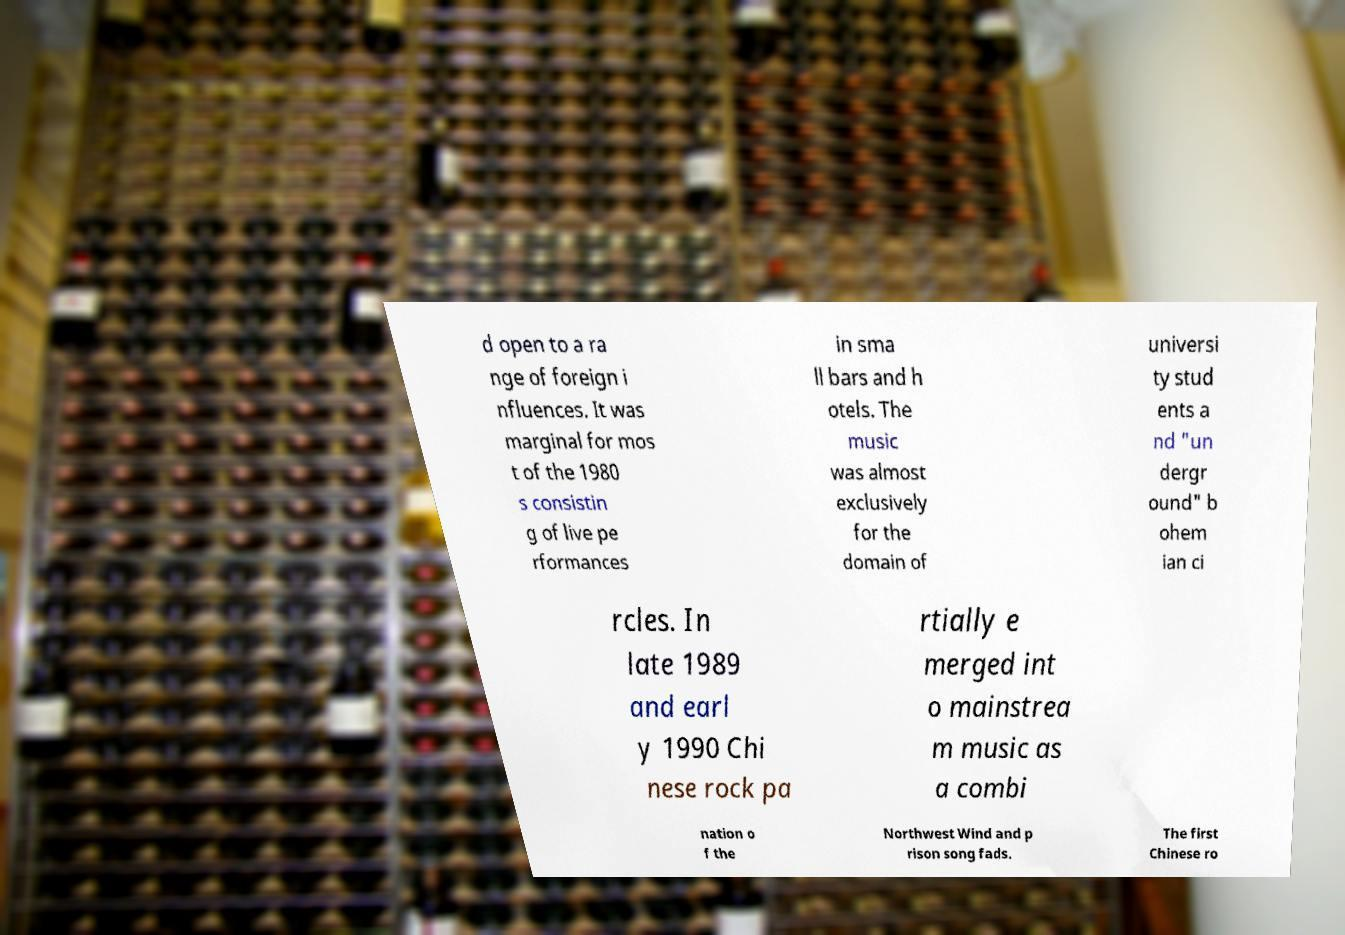Can you read and provide the text displayed in the image?This photo seems to have some interesting text. Can you extract and type it out for me? d open to a ra nge of foreign i nfluences. It was marginal for mos t of the 1980 s consistin g of live pe rformances in sma ll bars and h otels. The music was almost exclusively for the domain of universi ty stud ents a nd "un dergr ound" b ohem ian ci rcles. In late 1989 and earl y 1990 Chi nese rock pa rtially e merged int o mainstrea m music as a combi nation o f the Northwest Wind and p rison song fads. The first Chinese ro 